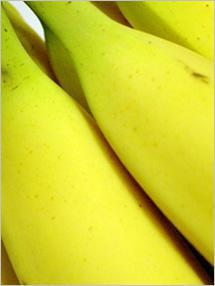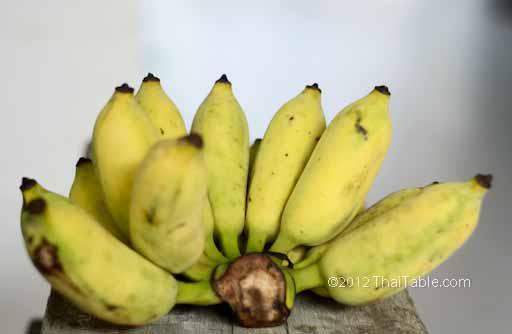The first image is the image on the left, the second image is the image on the right. Given the left and right images, does the statement "In at least one image there is a single attached group of bananas." hold true? Answer yes or no. Yes. The first image is the image on the left, the second image is the image on the right. Examine the images to the left and right. Is the description "All the bananas in the right image are in a bunch." accurate? Answer yes or no. Yes. 